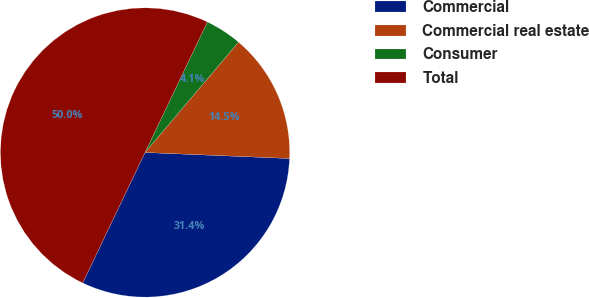<chart> <loc_0><loc_0><loc_500><loc_500><pie_chart><fcel>Commercial<fcel>Commercial real estate<fcel>Consumer<fcel>Total<nl><fcel>31.43%<fcel>14.48%<fcel>4.09%<fcel>50.0%<nl></chart> 